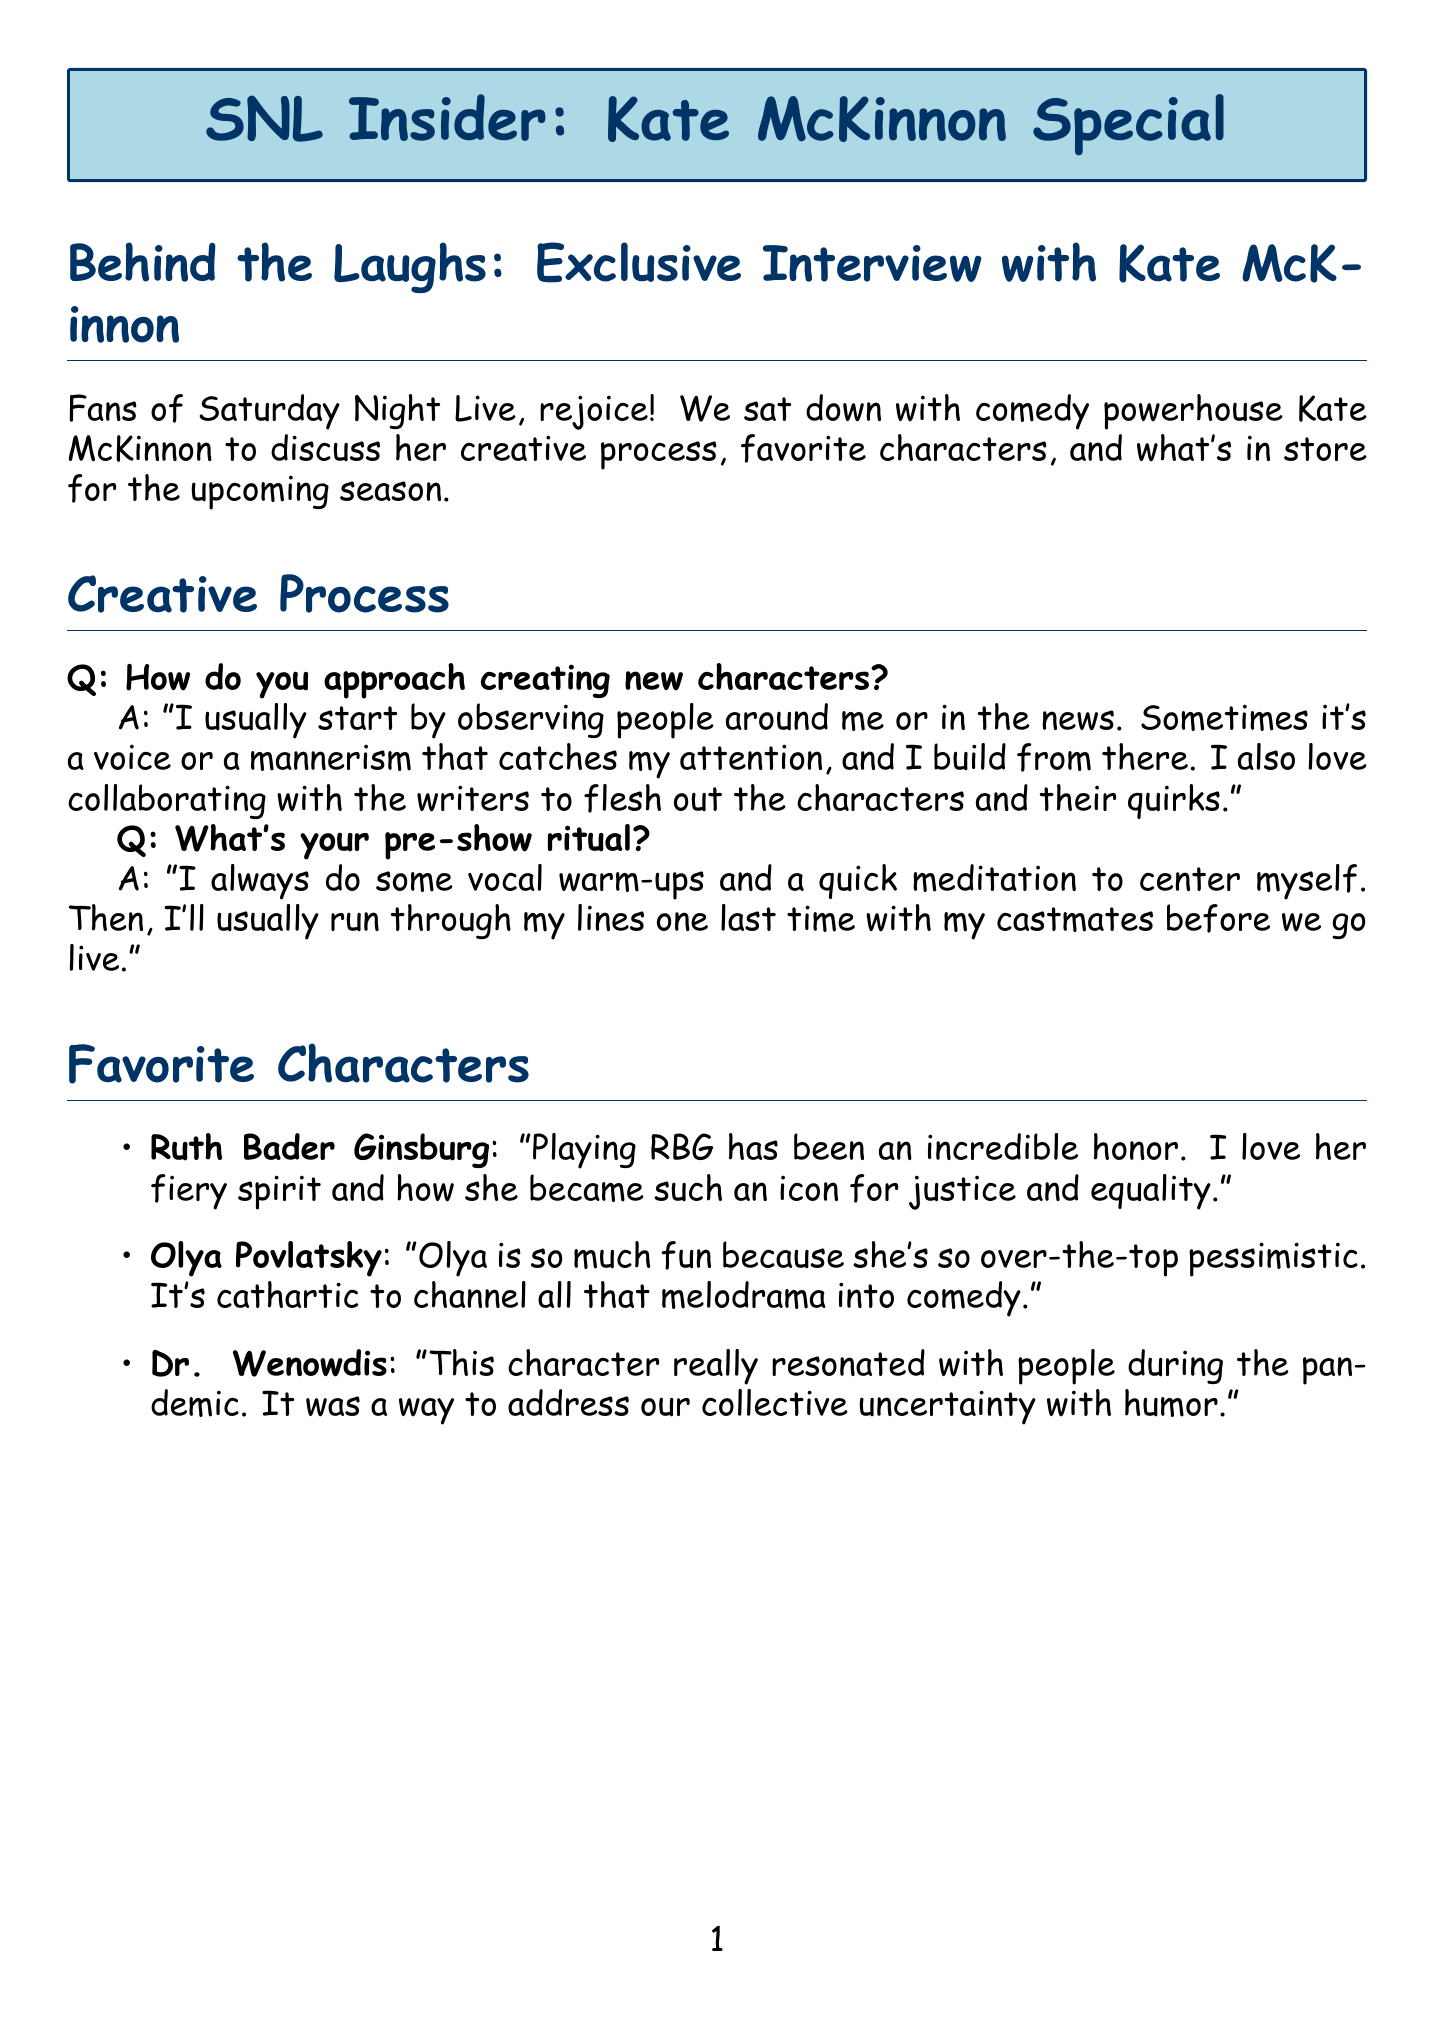How does Kate McKinnon describe her creative process? Kate describes her creative process as starting with observing people and then collaborating with writers to develop characters.
Answer: Observing people and collaborating with writers What character did Kate mention as resonating with people during the pandemic? Kate mentioned Dr. Wenowdis as a character that resonated with people during the pandemic.
Answer: Dr. Wenowdis What charity is Kate partnering with? Kate is partnering with The Trevor Project for awareness campaigns.
Answer: The Trevor Project How many wigs does the SNL costume department have for Kate's characters? The SNL costume department has over 50 wigs specifically for Kate's characters.
Answer: Over 50 wigs What is Kate's message to dedicated viewers? Kate expresses gratitude and encourages viewers to keep watching, laughing, and suggesting character ideas.
Answer: Grateful for support, keep watching and laughing What type of performance is Kate focusing on in her upcoming animated film? Kate is focusing on vocal performance for her upcoming animated film.
Answer: Vocal performance What sketch themes can viewers expect in the new SNL season? Viewers can expect timely political impersonations and possibly new recurring characters in the upcoming season.
Answer: Timely political impersonations and new recurring characters What quick activity does Kate do before her shows? Kate does some vocal warm-ups as part of her pre-show ritual.
Answer: Vocal warm-ups 